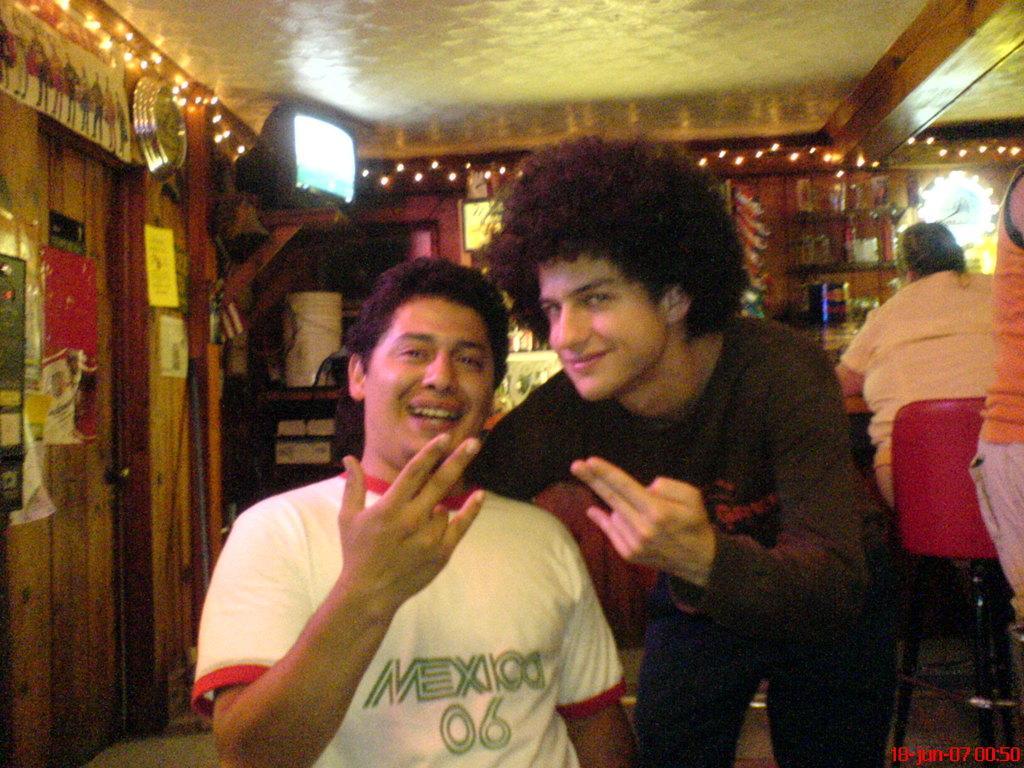Please provide a concise description of this image. In this image we can see two men. In the background on the right side we can see a person is sitting on a chair and another person is standing. We can see TV on a stand, decorative lights, posters, clock and other objects on the wall and there are objects on the stands. 